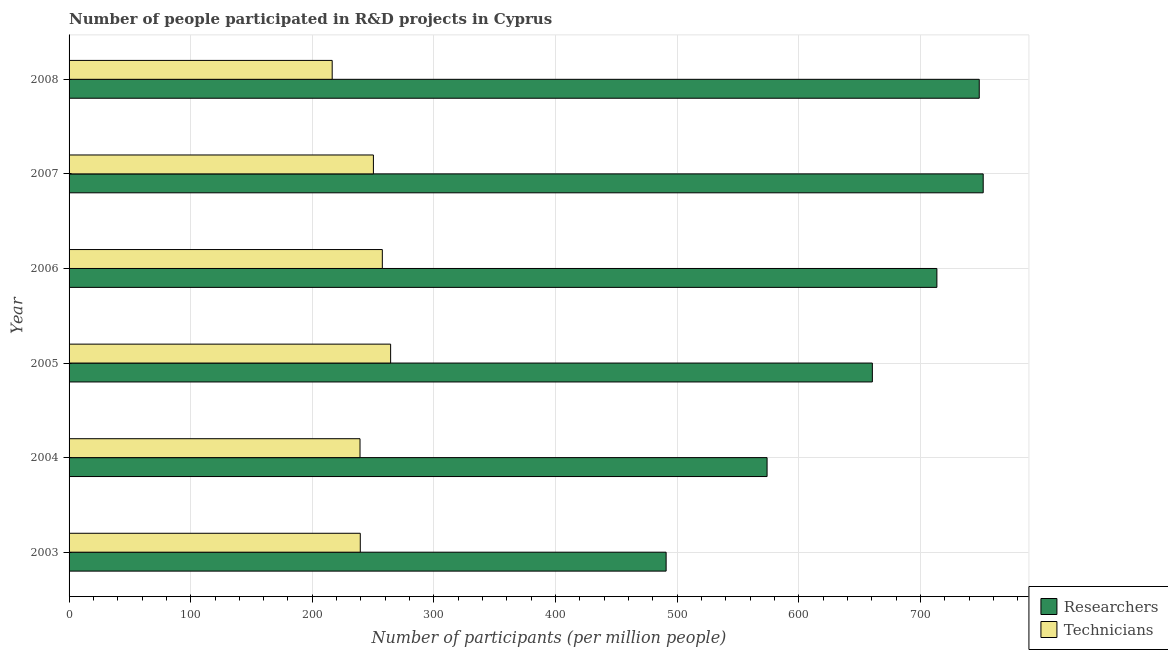How many groups of bars are there?
Offer a terse response. 6. Are the number of bars on each tick of the Y-axis equal?
Provide a short and direct response. Yes. How many bars are there on the 5th tick from the bottom?
Offer a terse response. 2. What is the label of the 1st group of bars from the top?
Your answer should be very brief. 2008. What is the number of technicians in 2008?
Offer a terse response. 216.34. Across all years, what is the maximum number of technicians?
Provide a short and direct response. 264.38. Across all years, what is the minimum number of researchers?
Make the answer very short. 490.91. In which year was the number of technicians maximum?
Your answer should be compact. 2005. In which year was the number of technicians minimum?
Provide a short and direct response. 2008. What is the total number of researchers in the graph?
Your response must be concise. 3938.83. What is the difference between the number of researchers in 2005 and that in 2007?
Offer a very short reply. -91.14. What is the difference between the number of researchers in 2004 and the number of technicians in 2007?
Your response must be concise. 323.69. What is the average number of researchers per year?
Provide a succinct answer. 656.47. In the year 2005, what is the difference between the number of researchers and number of technicians?
Give a very brief answer. 396.09. In how many years, is the number of researchers greater than 520 ?
Provide a succinct answer. 5. What is the ratio of the number of researchers in 2005 to that in 2006?
Your answer should be compact. 0.93. What is the difference between the highest and the second highest number of researchers?
Give a very brief answer. 3.25. What is the difference between the highest and the lowest number of technicians?
Offer a very short reply. 48.05. Is the sum of the number of technicians in 2003 and 2006 greater than the maximum number of researchers across all years?
Offer a very short reply. No. What does the 1st bar from the top in 2004 represents?
Ensure brevity in your answer.  Technicians. What does the 1st bar from the bottom in 2006 represents?
Your answer should be very brief. Researchers. Are all the bars in the graph horizontal?
Give a very brief answer. Yes. Does the graph contain grids?
Provide a succinct answer. Yes. Where does the legend appear in the graph?
Provide a succinct answer. Bottom right. How many legend labels are there?
Ensure brevity in your answer.  2. What is the title of the graph?
Give a very brief answer. Number of people participated in R&D projects in Cyprus. What is the label or title of the X-axis?
Keep it short and to the point. Number of participants (per million people). What is the Number of participants (per million people) of Researchers in 2003?
Ensure brevity in your answer.  490.91. What is the Number of participants (per million people) in Technicians in 2003?
Give a very brief answer. 239.44. What is the Number of participants (per million people) in Researchers in 2004?
Ensure brevity in your answer.  573.92. What is the Number of participants (per million people) of Technicians in 2004?
Give a very brief answer. 239.21. What is the Number of participants (per million people) in Researchers in 2005?
Offer a terse response. 660.48. What is the Number of participants (per million people) in Technicians in 2005?
Provide a short and direct response. 264.38. What is the Number of participants (per million people) in Researchers in 2006?
Your answer should be very brief. 713.54. What is the Number of participants (per million people) in Technicians in 2006?
Provide a short and direct response. 257.56. What is the Number of participants (per million people) of Researchers in 2007?
Offer a very short reply. 751.62. What is the Number of participants (per million people) in Technicians in 2007?
Your answer should be compact. 250.23. What is the Number of participants (per million people) of Researchers in 2008?
Give a very brief answer. 748.37. What is the Number of participants (per million people) of Technicians in 2008?
Give a very brief answer. 216.34. Across all years, what is the maximum Number of participants (per million people) in Researchers?
Keep it short and to the point. 751.62. Across all years, what is the maximum Number of participants (per million people) in Technicians?
Your answer should be very brief. 264.38. Across all years, what is the minimum Number of participants (per million people) in Researchers?
Offer a terse response. 490.91. Across all years, what is the minimum Number of participants (per million people) in Technicians?
Your answer should be compact. 216.34. What is the total Number of participants (per million people) of Researchers in the graph?
Ensure brevity in your answer.  3938.83. What is the total Number of participants (per million people) in Technicians in the graph?
Provide a succinct answer. 1467.17. What is the difference between the Number of participants (per million people) of Researchers in 2003 and that in 2004?
Keep it short and to the point. -83.01. What is the difference between the Number of participants (per million people) of Technicians in 2003 and that in 2004?
Offer a terse response. 0.23. What is the difference between the Number of participants (per million people) in Researchers in 2003 and that in 2005?
Your response must be concise. -169.57. What is the difference between the Number of participants (per million people) of Technicians in 2003 and that in 2005?
Keep it short and to the point. -24.94. What is the difference between the Number of participants (per million people) in Researchers in 2003 and that in 2006?
Your answer should be compact. -222.63. What is the difference between the Number of participants (per million people) in Technicians in 2003 and that in 2006?
Keep it short and to the point. -18.12. What is the difference between the Number of participants (per million people) of Researchers in 2003 and that in 2007?
Offer a very short reply. -260.71. What is the difference between the Number of participants (per million people) in Technicians in 2003 and that in 2007?
Provide a succinct answer. -10.78. What is the difference between the Number of participants (per million people) of Researchers in 2003 and that in 2008?
Your answer should be very brief. -257.46. What is the difference between the Number of participants (per million people) in Technicians in 2003 and that in 2008?
Your answer should be very brief. 23.1. What is the difference between the Number of participants (per million people) in Researchers in 2004 and that in 2005?
Offer a very short reply. -86.56. What is the difference between the Number of participants (per million people) of Technicians in 2004 and that in 2005?
Ensure brevity in your answer.  -25.17. What is the difference between the Number of participants (per million people) in Researchers in 2004 and that in 2006?
Your answer should be very brief. -139.62. What is the difference between the Number of participants (per million people) in Technicians in 2004 and that in 2006?
Ensure brevity in your answer.  -18.35. What is the difference between the Number of participants (per million people) of Researchers in 2004 and that in 2007?
Your answer should be compact. -177.7. What is the difference between the Number of participants (per million people) of Technicians in 2004 and that in 2007?
Ensure brevity in your answer.  -11.01. What is the difference between the Number of participants (per million people) in Researchers in 2004 and that in 2008?
Keep it short and to the point. -174.45. What is the difference between the Number of participants (per million people) of Technicians in 2004 and that in 2008?
Provide a short and direct response. 22.87. What is the difference between the Number of participants (per million people) in Researchers in 2005 and that in 2006?
Give a very brief answer. -53.06. What is the difference between the Number of participants (per million people) of Technicians in 2005 and that in 2006?
Give a very brief answer. 6.82. What is the difference between the Number of participants (per million people) in Researchers in 2005 and that in 2007?
Give a very brief answer. -91.14. What is the difference between the Number of participants (per million people) of Technicians in 2005 and that in 2007?
Provide a short and direct response. 14.16. What is the difference between the Number of participants (per million people) in Researchers in 2005 and that in 2008?
Give a very brief answer. -87.89. What is the difference between the Number of participants (per million people) in Technicians in 2005 and that in 2008?
Offer a very short reply. 48.05. What is the difference between the Number of participants (per million people) of Researchers in 2006 and that in 2007?
Provide a succinct answer. -38.08. What is the difference between the Number of participants (per million people) in Technicians in 2006 and that in 2007?
Your answer should be compact. 7.34. What is the difference between the Number of participants (per million people) of Researchers in 2006 and that in 2008?
Offer a very short reply. -34.83. What is the difference between the Number of participants (per million people) of Technicians in 2006 and that in 2008?
Ensure brevity in your answer.  41.22. What is the difference between the Number of participants (per million people) of Researchers in 2007 and that in 2008?
Keep it short and to the point. 3.25. What is the difference between the Number of participants (per million people) in Technicians in 2007 and that in 2008?
Your answer should be compact. 33.89. What is the difference between the Number of participants (per million people) in Researchers in 2003 and the Number of participants (per million people) in Technicians in 2004?
Provide a succinct answer. 251.69. What is the difference between the Number of participants (per million people) in Researchers in 2003 and the Number of participants (per million people) in Technicians in 2005?
Offer a terse response. 226.52. What is the difference between the Number of participants (per million people) of Researchers in 2003 and the Number of participants (per million people) of Technicians in 2006?
Make the answer very short. 233.35. What is the difference between the Number of participants (per million people) in Researchers in 2003 and the Number of participants (per million people) in Technicians in 2007?
Your answer should be compact. 240.68. What is the difference between the Number of participants (per million people) in Researchers in 2003 and the Number of participants (per million people) in Technicians in 2008?
Offer a terse response. 274.57. What is the difference between the Number of participants (per million people) in Researchers in 2004 and the Number of participants (per million people) in Technicians in 2005?
Your answer should be compact. 309.53. What is the difference between the Number of participants (per million people) of Researchers in 2004 and the Number of participants (per million people) of Technicians in 2006?
Your response must be concise. 316.36. What is the difference between the Number of participants (per million people) of Researchers in 2004 and the Number of participants (per million people) of Technicians in 2007?
Your response must be concise. 323.69. What is the difference between the Number of participants (per million people) in Researchers in 2004 and the Number of participants (per million people) in Technicians in 2008?
Provide a short and direct response. 357.58. What is the difference between the Number of participants (per million people) of Researchers in 2005 and the Number of participants (per million people) of Technicians in 2006?
Your answer should be very brief. 402.92. What is the difference between the Number of participants (per million people) in Researchers in 2005 and the Number of participants (per million people) in Technicians in 2007?
Provide a succinct answer. 410.25. What is the difference between the Number of participants (per million people) in Researchers in 2005 and the Number of participants (per million people) in Technicians in 2008?
Make the answer very short. 444.14. What is the difference between the Number of participants (per million people) in Researchers in 2006 and the Number of participants (per million people) in Technicians in 2007?
Offer a very short reply. 463.32. What is the difference between the Number of participants (per million people) of Researchers in 2006 and the Number of participants (per million people) of Technicians in 2008?
Your response must be concise. 497.2. What is the difference between the Number of participants (per million people) of Researchers in 2007 and the Number of participants (per million people) of Technicians in 2008?
Your answer should be compact. 535.28. What is the average Number of participants (per million people) in Researchers per year?
Keep it short and to the point. 656.47. What is the average Number of participants (per million people) of Technicians per year?
Your answer should be compact. 244.53. In the year 2003, what is the difference between the Number of participants (per million people) in Researchers and Number of participants (per million people) in Technicians?
Offer a terse response. 251.47. In the year 2004, what is the difference between the Number of participants (per million people) in Researchers and Number of participants (per million people) in Technicians?
Provide a succinct answer. 334.7. In the year 2005, what is the difference between the Number of participants (per million people) in Researchers and Number of participants (per million people) in Technicians?
Provide a short and direct response. 396.09. In the year 2006, what is the difference between the Number of participants (per million people) of Researchers and Number of participants (per million people) of Technicians?
Your answer should be compact. 455.98. In the year 2007, what is the difference between the Number of participants (per million people) in Researchers and Number of participants (per million people) in Technicians?
Your response must be concise. 501.39. In the year 2008, what is the difference between the Number of participants (per million people) in Researchers and Number of participants (per million people) in Technicians?
Ensure brevity in your answer.  532.03. What is the ratio of the Number of participants (per million people) in Researchers in 2003 to that in 2004?
Your response must be concise. 0.86. What is the ratio of the Number of participants (per million people) of Researchers in 2003 to that in 2005?
Offer a terse response. 0.74. What is the ratio of the Number of participants (per million people) in Technicians in 2003 to that in 2005?
Give a very brief answer. 0.91. What is the ratio of the Number of participants (per million people) in Researchers in 2003 to that in 2006?
Make the answer very short. 0.69. What is the ratio of the Number of participants (per million people) in Technicians in 2003 to that in 2006?
Your response must be concise. 0.93. What is the ratio of the Number of participants (per million people) in Researchers in 2003 to that in 2007?
Give a very brief answer. 0.65. What is the ratio of the Number of participants (per million people) in Technicians in 2003 to that in 2007?
Offer a terse response. 0.96. What is the ratio of the Number of participants (per million people) of Researchers in 2003 to that in 2008?
Your response must be concise. 0.66. What is the ratio of the Number of participants (per million people) in Technicians in 2003 to that in 2008?
Ensure brevity in your answer.  1.11. What is the ratio of the Number of participants (per million people) of Researchers in 2004 to that in 2005?
Provide a short and direct response. 0.87. What is the ratio of the Number of participants (per million people) of Technicians in 2004 to that in 2005?
Your answer should be very brief. 0.9. What is the ratio of the Number of participants (per million people) of Researchers in 2004 to that in 2006?
Your answer should be very brief. 0.8. What is the ratio of the Number of participants (per million people) in Technicians in 2004 to that in 2006?
Give a very brief answer. 0.93. What is the ratio of the Number of participants (per million people) in Researchers in 2004 to that in 2007?
Give a very brief answer. 0.76. What is the ratio of the Number of participants (per million people) of Technicians in 2004 to that in 2007?
Your answer should be very brief. 0.96. What is the ratio of the Number of participants (per million people) of Researchers in 2004 to that in 2008?
Your response must be concise. 0.77. What is the ratio of the Number of participants (per million people) of Technicians in 2004 to that in 2008?
Provide a short and direct response. 1.11. What is the ratio of the Number of participants (per million people) of Researchers in 2005 to that in 2006?
Offer a very short reply. 0.93. What is the ratio of the Number of participants (per million people) in Technicians in 2005 to that in 2006?
Make the answer very short. 1.03. What is the ratio of the Number of participants (per million people) of Researchers in 2005 to that in 2007?
Your answer should be very brief. 0.88. What is the ratio of the Number of participants (per million people) in Technicians in 2005 to that in 2007?
Offer a terse response. 1.06. What is the ratio of the Number of participants (per million people) in Researchers in 2005 to that in 2008?
Offer a terse response. 0.88. What is the ratio of the Number of participants (per million people) in Technicians in 2005 to that in 2008?
Your response must be concise. 1.22. What is the ratio of the Number of participants (per million people) of Researchers in 2006 to that in 2007?
Give a very brief answer. 0.95. What is the ratio of the Number of participants (per million people) in Technicians in 2006 to that in 2007?
Provide a succinct answer. 1.03. What is the ratio of the Number of participants (per million people) in Researchers in 2006 to that in 2008?
Your answer should be compact. 0.95. What is the ratio of the Number of participants (per million people) in Technicians in 2006 to that in 2008?
Offer a terse response. 1.19. What is the ratio of the Number of participants (per million people) of Technicians in 2007 to that in 2008?
Offer a terse response. 1.16. What is the difference between the highest and the second highest Number of participants (per million people) of Researchers?
Provide a succinct answer. 3.25. What is the difference between the highest and the second highest Number of participants (per million people) in Technicians?
Keep it short and to the point. 6.82. What is the difference between the highest and the lowest Number of participants (per million people) in Researchers?
Give a very brief answer. 260.71. What is the difference between the highest and the lowest Number of participants (per million people) of Technicians?
Give a very brief answer. 48.05. 